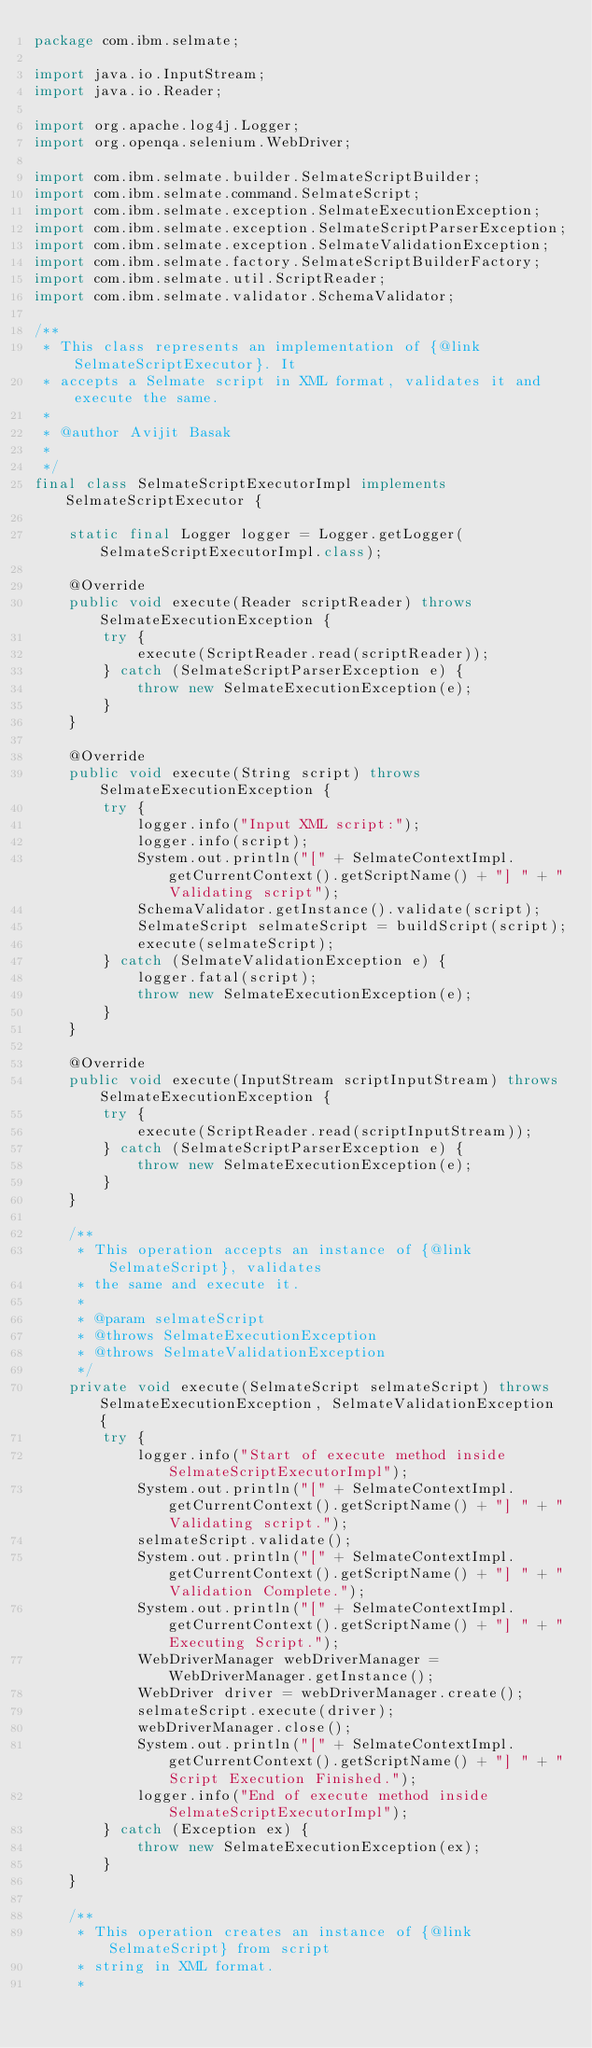Convert code to text. <code><loc_0><loc_0><loc_500><loc_500><_Java_>package com.ibm.selmate;

import java.io.InputStream;
import java.io.Reader;

import org.apache.log4j.Logger;
import org.openqa.selenium.WebDriver;

import com.ibm.selmate.builder.SelmateScriptBuilder;
import com.ibm.selmate.command.SelmateScript;
import com.ibm.selmate.exception.SelmateExecutionException;
import com.ibm.selmate.exception.SelmateScriptParserException;
import com.ibm.selmate.exception.SelmateValidationException;
import com.ibm.selmate.factory.SelmateScriptBuilderFactory;
import com.ibm.selmate.util.ScriptReader;
import com.ibm.selmate.validator.SchemaValidator;

/**
 * This class represents an implementation of {@link SelmateScriptExecutor}. It
 * accepts a Selmate script in XML format, validates it and execute the same.
 * 
 * @author Avijit Basak
 * 
 */
final class SelmateScriptExecutorImpl implements SelmateScriptExecutor {

	static final Logger logger = Logger.getLogger(SelmateScriptExecutorImpl.class);

	@Override
	public void execute(Reader scriptReader) throws SelmateExecutionException {
		try {
			execute(ScriptReader.read(scriptReader));
		} catch (SelmateScriptParserException e) {
			throw new SelmateExecutionException(e);
		}
	}

	@Override
	public void execute(String script) throws SelmateExecutionException {
		try {
			logger.info("Input XML script:");
			logger.info(script);
			System.out.println("[" + SelmateContextImpl.getCurrentContext().getScriptName() + "] " + "Validating script");
			SchemaValidator.getInstance().validate(script);
			SelmateScript selmateScript = buildScript(script);
			execute(selmateScript);
		} catch (SelmateValidationException e) {
			logger.fatal(script);
			throw new SelmateExecutionException(e);
		}
	}

	@Override
	public void execute(InputStream scriptInputStream) throws SelmateExecutionException {
		try {
			execute(ScriptReader.read(scriptInputStream));
		} catch (SelmateScriptParserException e) {
			throw new SelmateExecutionException(e);
		}
	}

	/**
	 * This operation accepts an instance of {@link SelmateScript}, validates
	 * the same and execute it.
	 * 
	 * @param selmateScript
	 * @throws SelmateExecutionException
	 * @throws SelmateValidationException
	 */
	private void execute(SelmateScript selmateScript) throws SelmateExecutionException, SelmateValidationException {
		try {
			logger.info("Start of execute method inside  SelmateScriptExecutorImpl");
			System.out.println("[" + SelmateContextImpl.getCurrentContext().getScriptName() + "] " + "Validating script.");
			selmateScript.validate();
			System.out.println("[" + SelmateContextImpl.getCurrentContext().getScriptName() + "] " + "Validation Complete.");
			System.out.println("[" + SelmateContextImpl.getCurrentContext().getScriptName() + "] " + "Executing Script.");
			WebDriverManager webDriverManager = WebDriverManager.getInstance();
			WebDriver driver = webDriverManager.create();
			selmateScript.execute(driver);
			webDriverManager.close();
			System.out.println("[" + SelmateContextImpl.getCurrentContext().getScriptName() + "] " + "Script Execution Finished.");
			logger.info("End of execute method inside  SelmateScriptExecutorImpl");
		} catch (Exception ex) {
			throw new SelmateExecutionException(ex);
		}
	}

	/**
	 * This operation creates an instance of {@link SelmateScript} from script
	 * string in XML format.
	 * </code> 